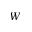Convert formula to latex. <formula><loc_0><loc_0><loc_500><loc_500>W</formula> 